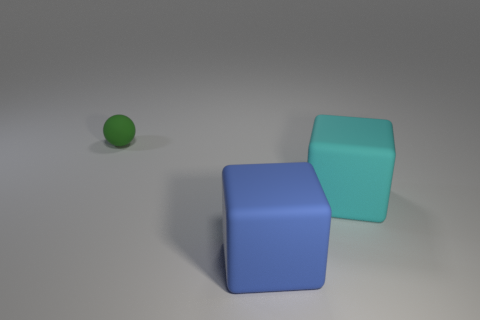Add 2 rubber cubes. How many objects exist? 5 Subtract all blocks. How many objects are left? 1 Add 2 cyan objects. How many cyan objects are left? 3 Add 3 large blue objects. How many large blue objects exist? 4 Subtract 0 red balls. How many objects are left? 3 Subtract all green spheres. Subtract all big cyan objects. How many objects are left? 1 